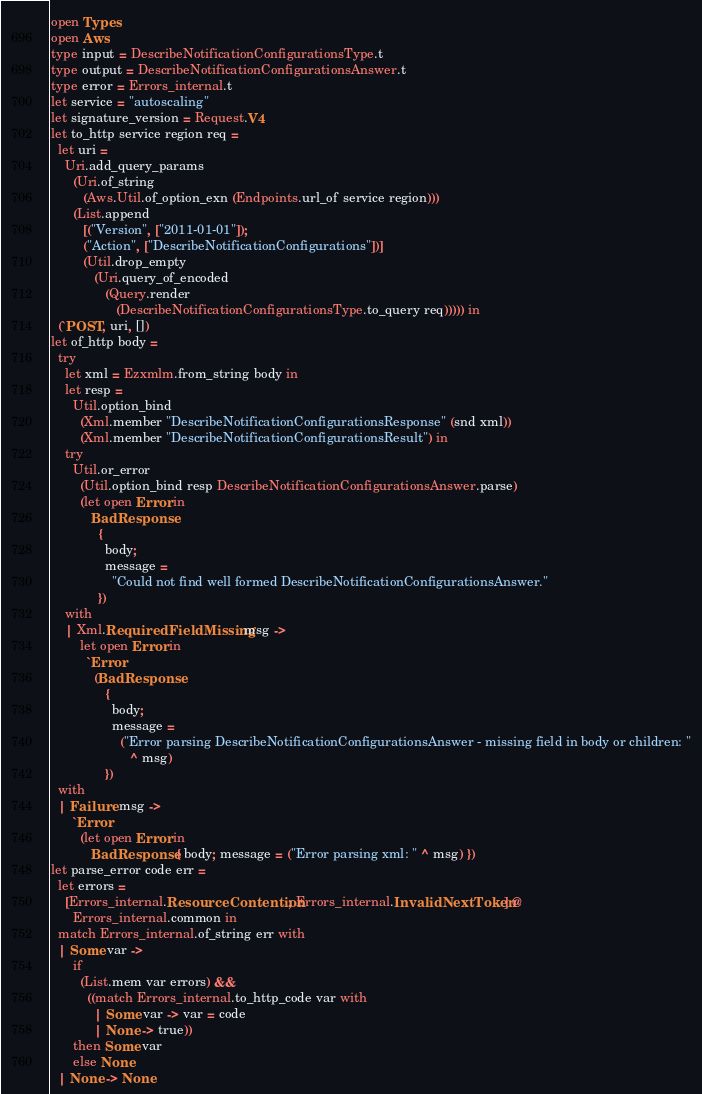Convert code to text. <code><loc_0><loc_0><loc_500><loc_500><_OCaml_>open Types
open Aws
type input = DescribeNotificationConfigurationsType.t
type output = DescribeNotificationConfigurationsAnswer.t
type error = Errors_internal.t
let service = "autoscaling"
let signature_version = Request.V4
let to_http service region req =
  let uri =
    Uri.add_query_params
      (Uri.of_string
         (Aws.Util.of_option_exn (Endpoints.url_of service region)))
      (List.append
         [("Version", ["2011-01-01"]);
         ("Action", ["DescribeNotificationConfigurations"])]
         (Util.drop_empty
            (Uri.query_of_encoded
               (Query.render
                  (DescribeNotificationConfigurationsType.to_query req))))) in
  (`POST, uri, [])
let of_http body =
  try
    let xml = Ezxmlm.from_string body in
    let resp =
      Util.option_bind
        (Xml.member "DescribeNotificationConfigurationsResponse" (snd xml))
        (Xml.member "DescribeNotificationConfigurationsResult") in
    try
      Util.or_error
        (Util.option_bind resp DescribeNotificationConfigurationsAnswer.parse)
        (let open Error in
           BadResponse
             {
               body;
               message =
                 "Could not find well formed DescribeNotificationConfigurationsAnswer."
             })
    with
    | Xml.RequiredFieldMissing msg ->
        let open Error in
          `Error
            (BadResponse
               {
                 body;
                 message =
                   ("Error parsing DescribeNotificationConfigurationsAnswer - missing field in body or children: "
                      ^ msg)
               })
  with
  | Failure msg ->
      `Error
        (let open Error in
           BadResponse { body; message = ("Error parsing xml: " ^ msg) })
let parse_error code err =
  let errors =
    [Errors_internal.ResourceContention; Errors_internal.InvalidNextToken] @
      Errors_internal.common in
  match Errors_internal.of_string err with
  | Some var ->
      if
        (List.mem var errors) &&
          ((match Errors_internal.to_http_code var with
            | Some var -> var = code
            | None -> true))
      then Some var
      else None
  | None -> None</code> 